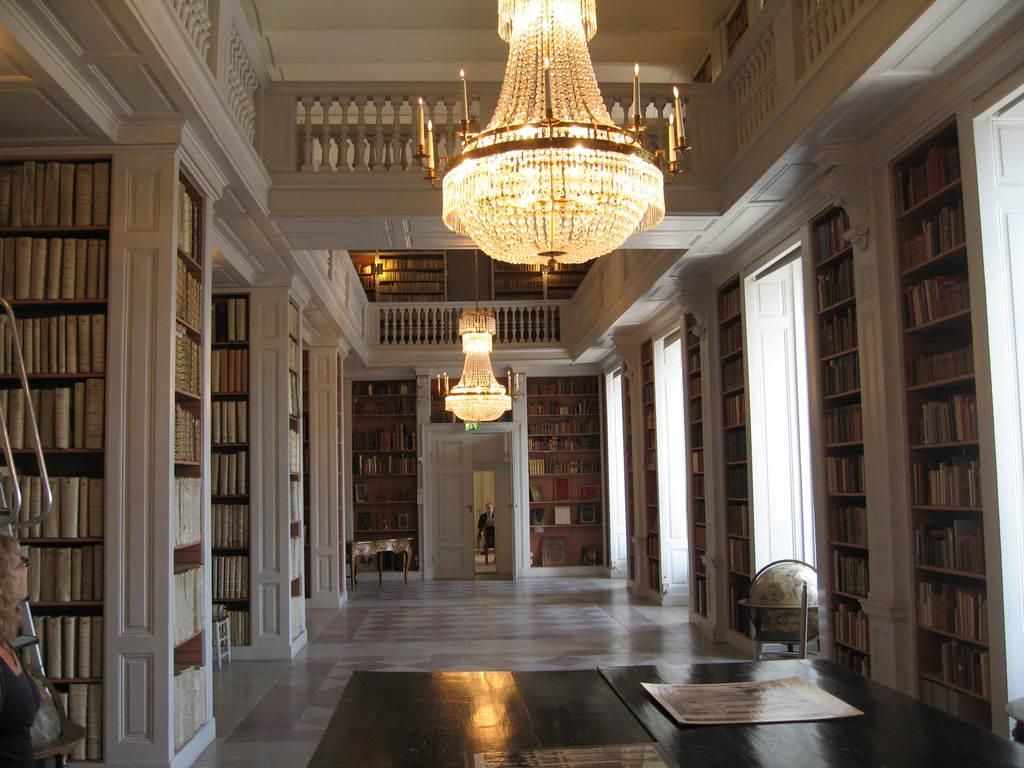What can be seen arranged on shelves in the image? There are books arranged on shelves in the image. What type of illumination is present in the image? There are lights visible in the image. Can you describe the person in the image? There is a person in the image. What architectural features are present in the image? There are doors in the image. What type of furniture can be seen in the image? There is a table in the image. What surface is visible beneath the furniture and shelves? There is a floor visible in the image. What type of cemetery can be seen in the image? There is no cemetery present in the image. 